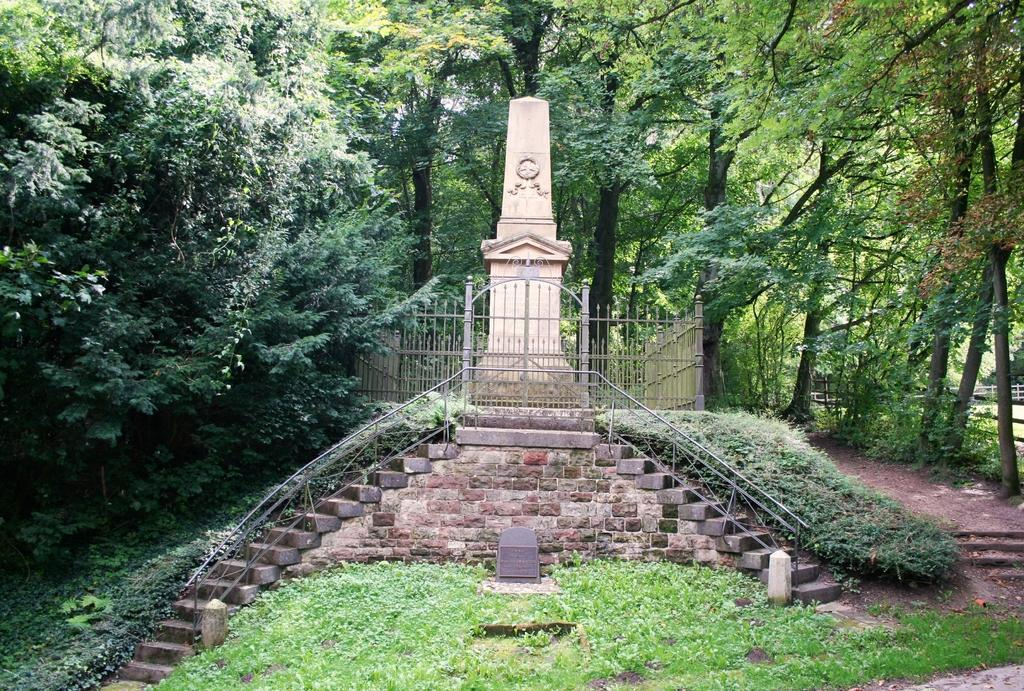What is the main subject of the image? There is a memorial in the image. What architectural feature can be seen in the image? There are steps in the image. What type of vegetation is present in the image? Grass and trees are visible in the image. What type of barrier is present in the image? Fences are visible in the image. What type of cherry is growing on the trees in the image? There are no cherries mentioned or visible in the image; only trees are present. What type of treatment is being administered to the memorial in the image? There is no treatment being administered to the memorial in the image; it is a static structure. 